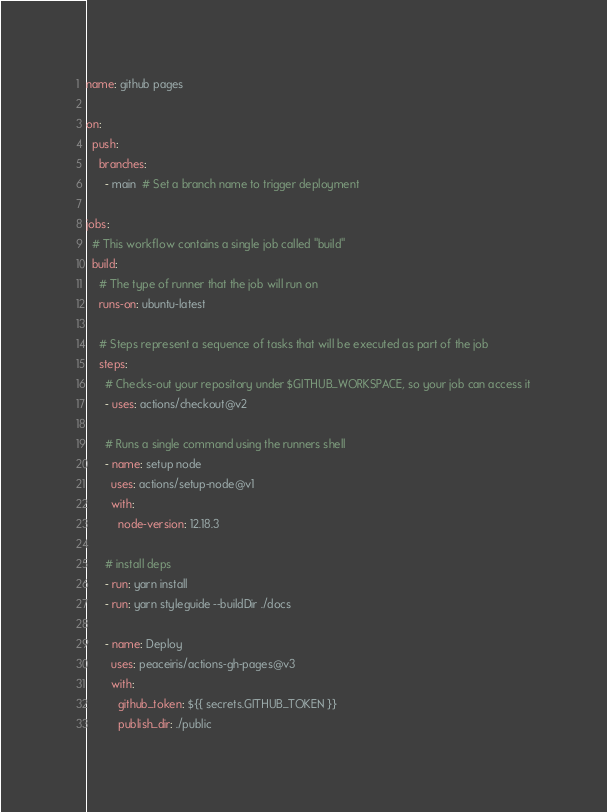Convert code to text. <code><loc_0><loc_0><loc_500><loc_500><_YAML_>name: github pages

on:
  push:
    branches:
      - main  # Set a branch name to trigger deployment

jobs:
  # This workflow contains a single job called "build"
  build:
    # The type of runner that the job will run on
    runs-on: ubuntu-latest

    # Steps represent a sequence of tasks that will be executed as part of the job
    steps:
      # Checks-out your repository under $GITHUB_WORKSPACE, so your job can access it
      - uses: actions/checkout@v2

      # Runs a single command using the runners shell
      - name: setup node
        uses: actions/setup-node@v1
        with:
          node-version: 12.18.3
          
      # install deps
      - run: yarn install
      - run: yarn styleguide --buildDir ./docs

      - name: Deploy
        uses: peaceiris/actions-gh-pages@v3
        with:
          github_token: ${{ secrets.GITHUB_TOKEN }}
          publish_dir: ./public
</code> 